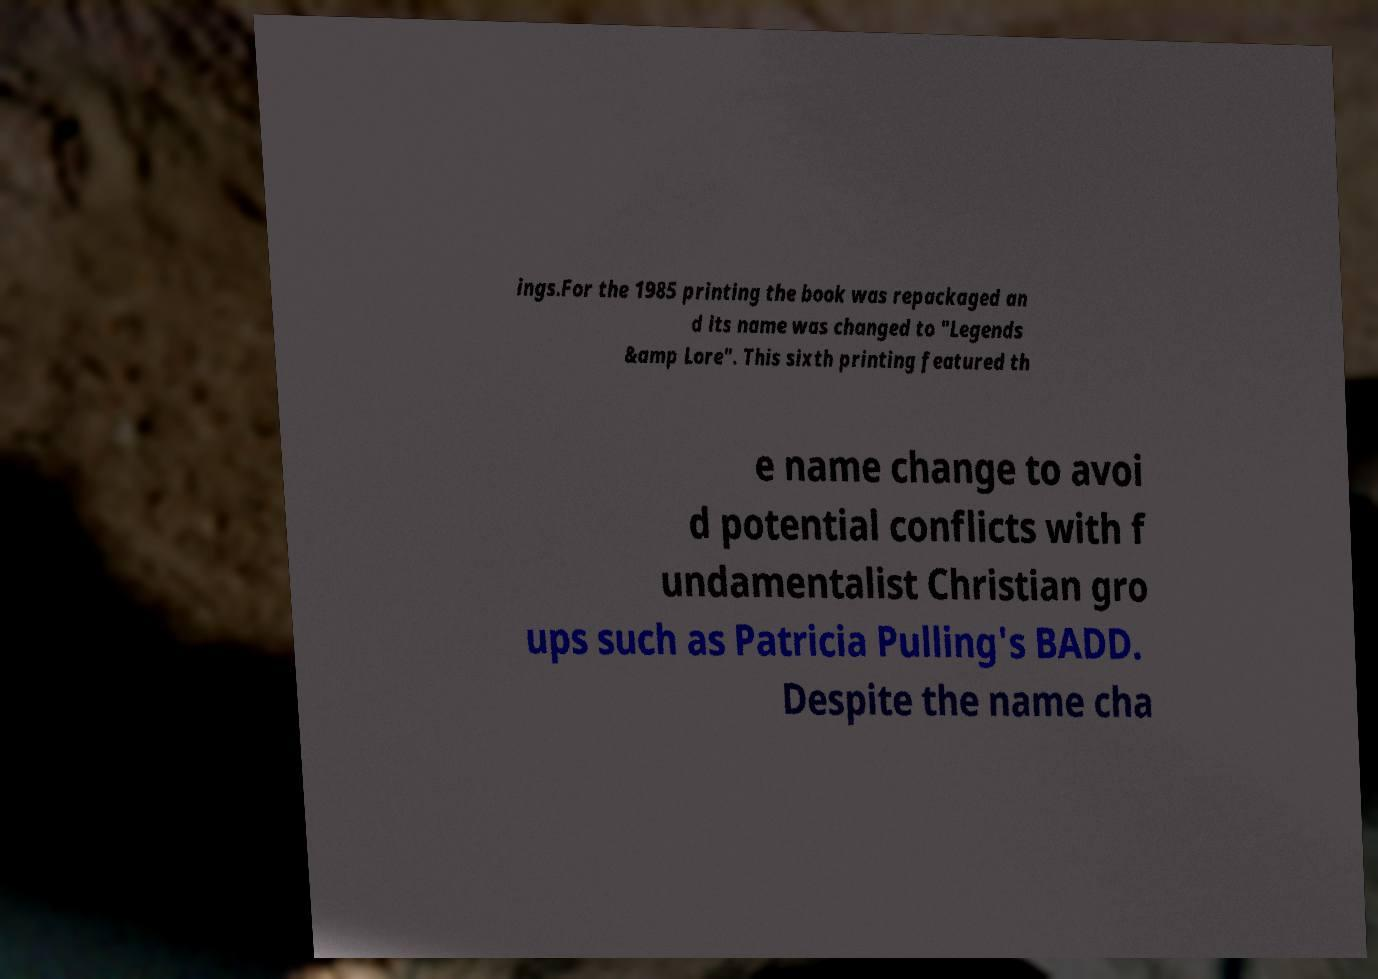For documentation purposes, I need the text within this image transcribed. Could you provide that? ings.For the 1985 printing the book was repackaged an d its name was changed to "Legends &amp Lore". This sixth printing featured th e name change to avoi d potential conflicts with f undamentalist Christian gro ups such as Patricia Pulling's BADD. Despite the name cha 